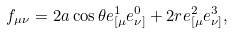Convert formula to latex. <formula><loc_0><loc_0><loc_500><loc_500>f _ { \mu \nu } = 2 a \cos \theta e ^ { 1 } _ { [ \mu } e ^ { 0 } _ { \nu ] } + 2 r e ^ { 2 } _ { [ \mu } e ^ { 3 } _ { \nu ] } ,</formula> 